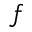<formula> <loc_0><loc_0><loc_500><loc_500>f</formula> 